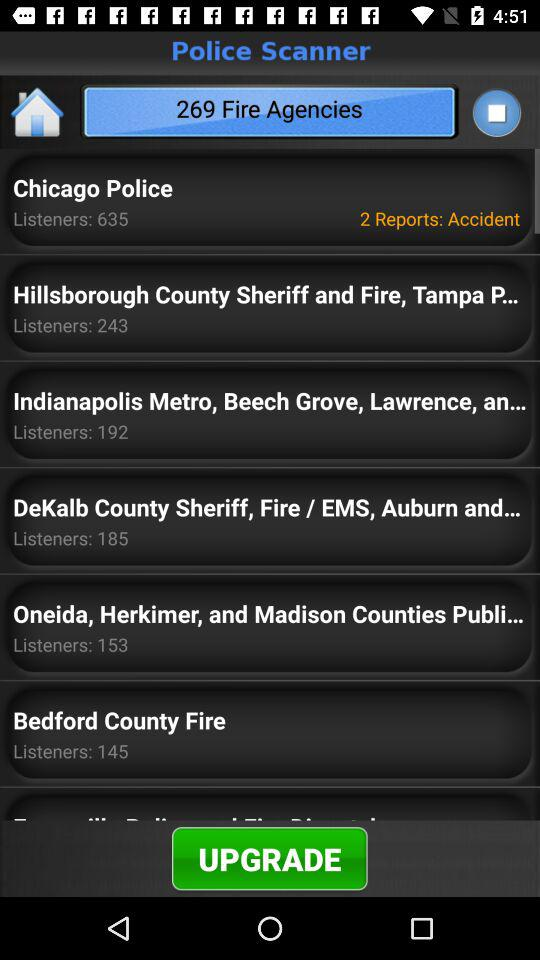What is the application name? The application name is "Police Scanner". 